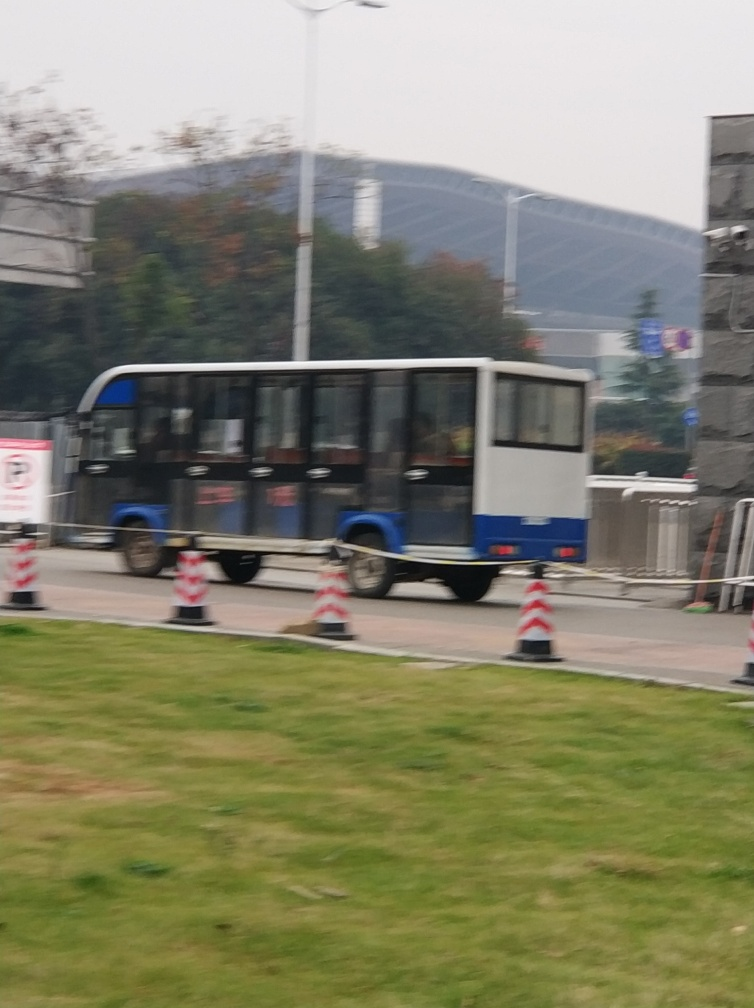Is it difficult to see the outlines of the distant buildings? Given the visible haziness and the lack of sharpness in the image, it is indeed more challenging to discern the outlines of the distant buildings clearly. The atmospheric conditions, as suggested by the blurred appearance, might be contributing to this visual difficulty. 